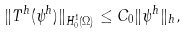Convert formula to latex. <formula><loc_0><loc_0><loc_500><loc_500>\| T ^ { h } ( \psi ^ { h } ) \| _ { H ^ { 1 } _ { 0 } ( \Omega ) } \leq C _ { 0 } \| \psi ^ { h } \| _ { h } ,</formula> 